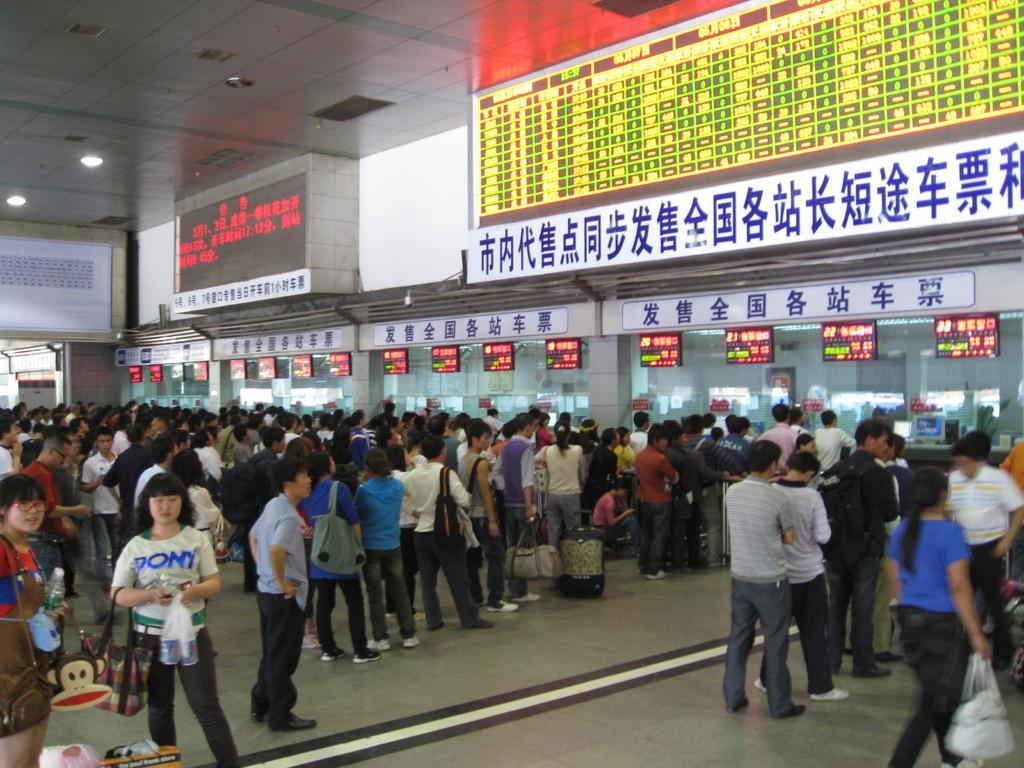Can you describe this image briefly? In this image I can see the group of people with different color dresses and I can see few people with bags. In-front of these people I can see many boards and there are few led boards can be seen. 